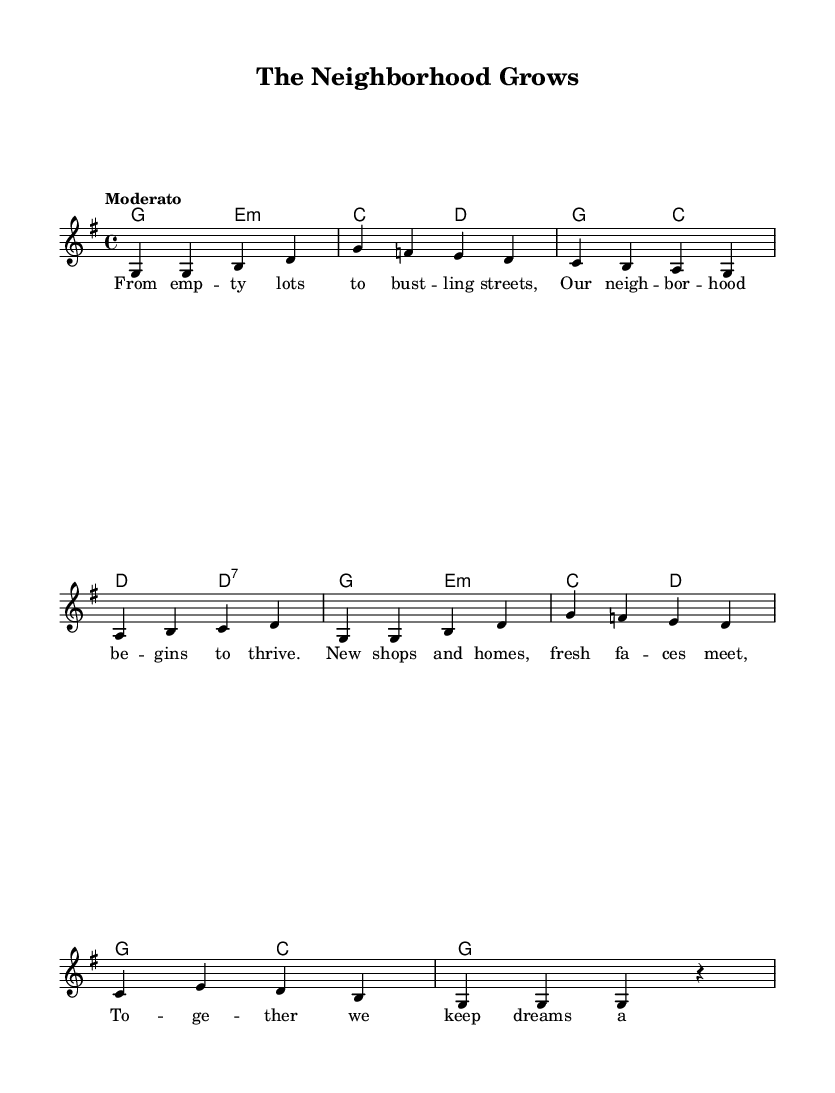What is the key signature of this music? The key signature is G major, which has one sharp (F#). This is indicated at the beginning of the staff, where the sharp symbol appears.
Answer: G major What is the time signature of the piece? The time signature is 4/4, which is indicated at the beginning of the score. It means there are four beats in each measure, and the quarter note gets one beat.
Answer: 4/4 What is the tempo marking for the music? The tempo marking is "Moderato," which suggests a moderate pace for the performance of the piece. This is found above the staff at the start of the score.
Answer: Moderato How many measures are in the melody? There are eight measures in the melody. This can be counted by numbering each section of the staff between the bar lines, indicating the end of each measure.
Answer: Eight Which chord follows the D7 chord in the harmony section? The next chord that follows the D7 chord is G. This can be determined by analyzing the sequence of chords written below the melody.
Answer: G What theme is presented in the lyrics? The theme presented in the lyrics is community growth and development. This can be inferred from phrases in the lyrics that reference empty lots, bustling streets, and new shops and homes coming together.
Answer: Community growth What type of song is "The Neighborhood Grows"? "The Neighborhood Grows" is a folk song. This classification is derived from its storytelling aspect and focus on the local community and neighborhood development, typical of folk song traditions.
Answer: Folk song 